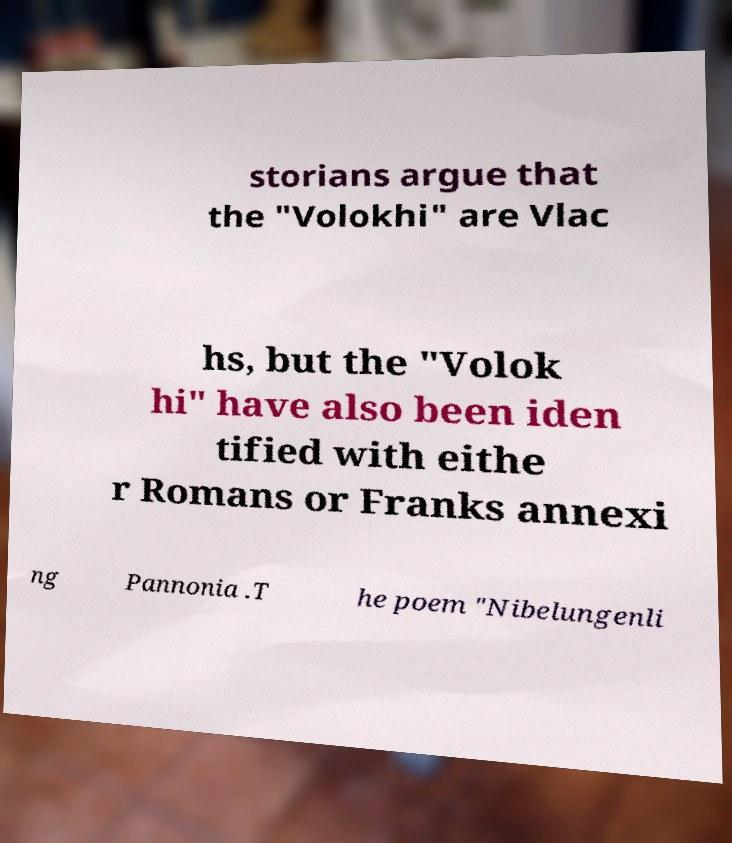I need the written content from this picture converted into text. Can you do that? storians argue that the "Volokhi" are Vlac hs, but the "Volok hi" have also been iden tified with eithe r Romans or Franks annexi ng Pannonia .T he poem "Nibelungenli 